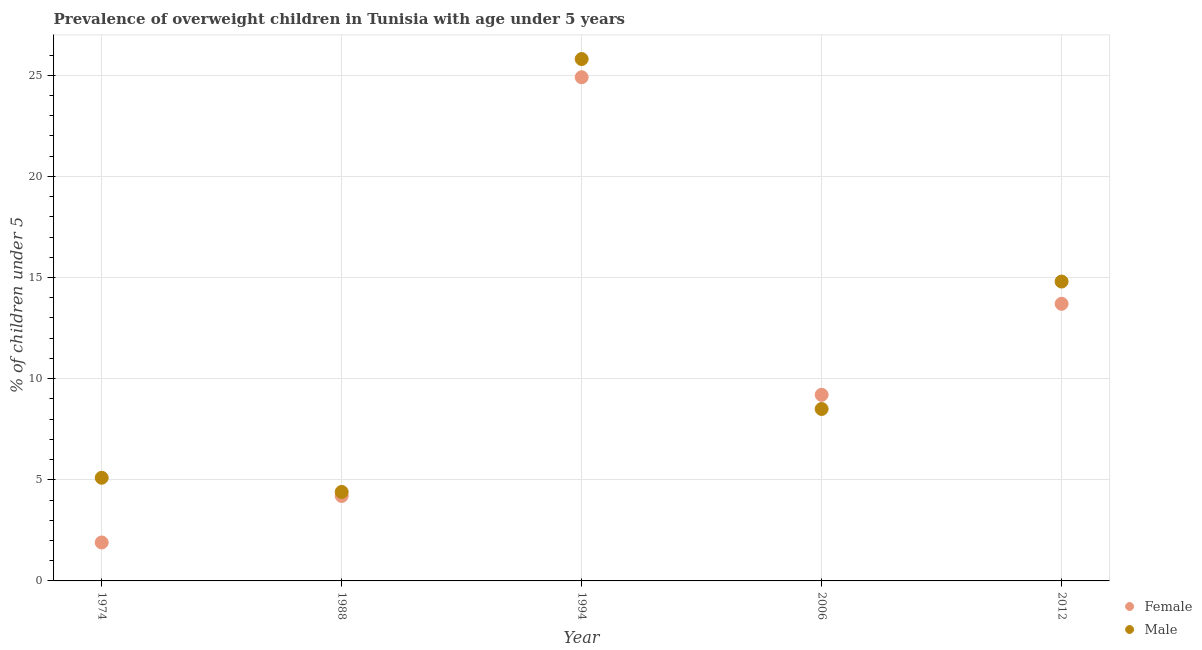What is the percentage of obese female children in 2012?
Offer a very short reply. 13.7. Across all years, what is the maximum percentage of obese male children?
Your response must be concise. 25.8. Across all years, what is the minimum percentage of obese female children?
Provide a short and direct response. 1.9. In which year was the percentage of obese male children maximum?
Offer a terse response. 1994. In which year was the percentage of obese female children minimum?
Give a very brief answer. 1974. What is the total percentage of obese male children in the graph?
Provide a succinct answer. 58.6. What is the difference between the percentage of obese male children in 1974 and that in 2012?
Make the answer very short. -9.7. What is the difference between the percentage of obese male children in 2006 and the percentage of obese female children in 2012?
Keep it short and to the point. -5.2. What is the average percentage of obese female children per year?
Ensure brevity in your answer.  10.78. In the year 2006, what is the difference between the percentage of obese male children and percentage of obese female children?
Offer a terse response. -0.7. What is the ratio of the percentage of obese female children in 2006 to that in 2012?
Offer a very short reply. 0.67. Is the percentage of obese male children in 1974 less than that in 1988?
Offer a terse response. No. What is the difference between the highest and the second highest percentage of obese male children?
Offer a very short reply. 11. What is the difference between the highest and the lowest percentage of obese male children?
Your answer should be compact. 21.4. In how many years, is the percentage of obese female children greater than the average percentage of obese female children taken over all years?
Provide a succinct answer. 2. Is the sum of the percentage of obese female children in 1994 and 2012 greater than the maximum percentage of obese male children across all years?
Make the answer very short. Yes. Does the percentage of obese female children monotonically increase over the years?
Ensure brevity in your answer.  No. Is the percentage of obese female children strictly greater than the percentage of obese male children over the years?
Give a very brief answer. No. Is the percentage of obese male children strictly less than the percentage of obese female children over the years?
Make the answer very short. No. How many dotlines are there?
Provide a short and direct response. 2. How many years are there in the graph?
Your answer should be very brief. 5. What is the difference between two consecutive major ticks on the Y-axis?
Offer a very short reply. 5. Are the values on the major ticks of Y-axis written in scientific E-notation?
Offer a very short reply. No. Does the graph contain grids?
Give a very brief answer. Yes. Where does the legend appear in the graph?
Make the answer very short. Bottom right. What is the title of the graph?
Ensure brevity in your answer.  Prevalence of overweight children in Tunisia with age under 5 years. Does "Age 65(female)" appear as one of the legend labels in the graph?
Your answer should be compact. No. What is the label or title of the Y-axis?
Offer a terse response.  % of children under 5. What is the  % of children under 5 of Female in 1974?
Your answer should be compact. 1.9. What is the  % of children under 5 of Male in 1974?
Your answer should be very brief. 5.1. What is the  % of children under 5 in Female in 1988?
Provide a short and direct response. 4.2. What is the  % of children under 5 of Male in 1988?
Your response must be concise. 4.4. What is the  % of children under 5 in Female in 1994?
Provide a short and direct response. 24.9. What is the  % of children under 5 of Male in 1994?
Give a very brief answer. 25.8. What is the  % of children under 5 in Female in 2006?
Your answer should be very brief. 9.2. What is the  % of children under 5 of Male in 2006?
Make the answer very short. 8.5. What is the  % of children under 5 of Female in 2012?
Offer a terse response. 13.7. What is the  % of children under 5 in Male in 2012?
Keep it short and to the point. 14.8. Across all years, what is the maximum  % of children under 5 of Female?
Offer a terse response. 24.9. Across all years, what is the maximum  % of children under 5 of Male?
Make the answer very short. 25.8. Across all years, what is the minimum  % of children under 5 of Female?
Provide a short and direct response. 1.9. Across all years, what is the minimum  % of children under 5 in Male?
Your answer should be compact. 4.4. What is the total  % of children under 5 of Female in the graph?
Provide a succinct answer. 53.9. What is the total  % of children under 5 in Male in the graph?
Your answer should be compact. 58.6. What is the difference between the  % of children under 5 in Female in 1974 and that in 1988?
Offer a very short reply. -2.3. What is the difference between the  % of children under 5 in Male in 1974 and that in 1988?
Your response must be concise. 0.7. What is the difference between the  % of children under 5 of Male in 1974 and that in 1994?
Give a very brief answer. -20.7. What is the difference between the  % of children under 5 of Male in 1974 and that in 2006?
Your answer should be very brief. -3.4. What is the difference between the  % of children under 5 of Female in 1974 and that in 2012?
Make the answer very short. -11.8. What is the difference between the  % of children under 5 in Male in 1974 and that in 2012?
Provide a succinct answer. -9.7. What is the difference between the  % of children under 5 in Female in 1988 and that in 1994?
Keep it short and to the point. -20.7. What is the difference between the  % of children under 5 in Male in 1988 and that in 1994?
Provide a short and direct response. -21.4. What is the difference between the  % of children under 5 of Female in 1988 and that in 2012?
Your answer should be compact. -9.5. What is the difference between the  % of children under 5 in Male in 1988 and that in 2012?
Keep it short and to the point. -10.4. What is the difference between the  % of children under 5 in Female in 1994 and that in 2006?
Make the answer very short. 15.7. What is the difference between the  % of children under 5 in Male in 1994 and that in 2006?
Keep it short and to the point. 17.3. What is the difference between the  % of children under 5 in Female in 1994 and that in 2012?
Provide a succinct answer. 11.2. What is the difference between the  % of children under 5 of Female in 1974 and the  % of children under 5 of Male in 1994?
Make the answer very short. -23.9. What is the difference between the  % of children under 5 of Female in 1974 and the  % of children under 5 of Male in 2006?
Ensure brevity in your answer.  -6.6. What is the difference between the  % of children under 5 in Female in 1974 and the  % of children under 5 in Male in 2012?
Your answer should be compact. -12.9. What is the difference between the  % of children under 5 of Female in 1988 and the  % of children under 5 of Male in 1994?
Ensure brevity in your answer.  -21.6. What is the difference between the  % of children under 5 of Female in 1994 and the  % of children under 5 of Male in 2012?
Provide a short and direct response. 10.1. What is the difference between the  % of children under 5 of Female in 2006 and the  % of children under 5 of Male in 2012?
Your answer should be very brief. -5.6. What is the average  % of children under 5 in Female per year?
Provide a succinct answer. 10.78. What is the average  % of children under 5 in Male per year?
Ensure brevity in your answer.  11.72. In the year 1974, what is the difference between the  % of children under 5 of Female and  % of children under 5 of Male?
Your answer should be very brief. -3.2. In the year 1988, what is the difference between the  % of children under 5 of Female and  % of children under 5 of Male?
Keep it short and to the point. -0.2. What is the ratio of the  % of children under 5 of Female in 1974 to that in 1988?
Provide a succinct answer. 0.45. What is the ratio of the  % of children under 5 in Male in 1974 to that in 1988?
Your answer should be compact. 1.16. What is the ratio of the  % of children under 5 in Female in 1974 to that in 1994?
Provide a succinct answer. 0.08. What is the ratio of the  % of children under 5 of Male in 1974 to that in 1994?
Make the answer very short. 0.2. What is the ratio of the  % of children under 5 of Female in 1974 to that in 2006?
Keep it short and to the point. 0.21. What is the ratio of the  % of children under 5 in Male in 1974 to that in 2006?
Offer a very short reply. 0.6. What is the ratio of the  % of children under 5 of Female in 1974 to that in 2012?
Your answer should be compact. 0.14. What is the ratio of the  % of children under 5 in Male in 1974 to that in 2012?
Provide a succinct answer. 0.34. What is the ratio of the  % of children under 5 of Female in 1988 to that in 1994?
Provide a short and direct response. 0.17. What is the ratio of the  % of children under 5 in Male in 1988 to that in 1994?
Ensure brevity in your answer.  0.17. What is the ratio of the  % of children under 5 in Female in 1988 to that in 2006?
Give a very brief answer. 0.46. What is the ratio of the  % of children under 5 of Male in 1988 to that in 2006?
Offer a very short reply. 0.52. What is the ratio of the  % of children under 5 of Female in 1988 to that in 2012?
Your answer should be compact. 0.31. What is the ratio of the  % of children under 5 in Male in 1988 to that in 2012?
Provide a short and direct response. 0.3. What is the ratio of the  % of children under 5 in Female in 1994 to that in 2006?
Your answer should be very brief. 2.71. What is the ratio of the  % of children under 5 in Male in 1994 to that in 2006?
Your answer should be very brief. 3.04. What is the ratio of the  % of children under 5 of Female in 1994 to that in 2012?
Make the answer very short. 1.82. What is the ratio of the  % of children under 5 of Male in 1994 to that in 2012?
Offer a very short reply. 1.74. What is the ratio of the  % of children under 5 in Female in 2006 to that in 2012?
Keep it short and to the point. 0.67. What is the ratio of the  % of children under 5 of Male in 2006 to that in 2012?
Keep it short and to the point. 0.57. What is the difference between the highest and the lowest  % of children under 5 in Female?
Offer a terse response. 23. What is the difference between the highest and the lowest  % of children under 5 in Male?
Your answer should be very brief. 21.4. 